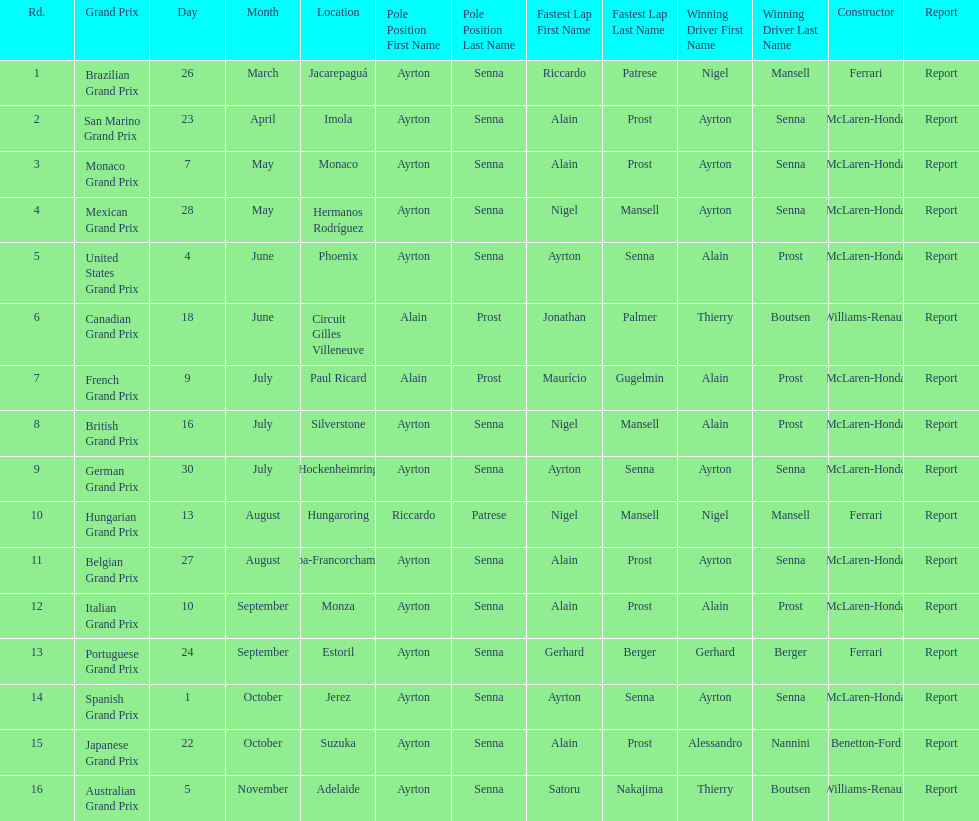Who had the fastest lap at the german grand prix? Ayrton Senna. 